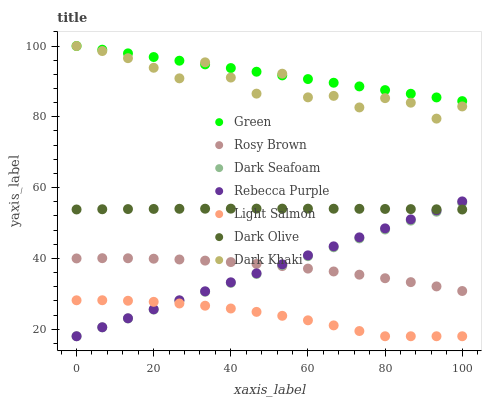Does Light Salmon have the minimum area under the curve?
Answer yes or no. Yes. Does Green have the maximum area under the curve?
Answer yes or no. Yes. Does Rosy Brown have the minimum area under the curve?
Answer yes or no. No. Does Rosy Brown have the maximum area under the curve?
Answer yes or no. No. Is Rebecca Purple the smoothest?
Answer yes or no. Yes. Is Dark Khaki the roughest?
Answer yes or no. Yes. Is Rosy Brown the smoothest?
Answer yes or no. No. Is Rosy Brown the roughest?
Answer yes or no. No. Does Light Salmon have the lowest value?
Answer yes or no. Yes. Does Rosy Brown have the lowest value?
Answer yes or no. No. Does Green have the highest value?
Answer yes or no. Yes. Does Rosy Brown have the highest value?
Answer yes or no. No. Is Light Salmon less than Green?
Answer yes or no. Yes. Is Dark Khaki greater than Dark Seafoam?
Answer yes or no. Yes. Does Dark Seafoam intersect Dark Olive?
Answer yes or no. Yes. Is Dark Seafoam less than Dark Olive?
Answer yes or no. No. Is Dark Seafoam greater than Dark Olive?
Answer yes or no. No. Does Light Salmon intersect Green?
Answer yes or no. No. 